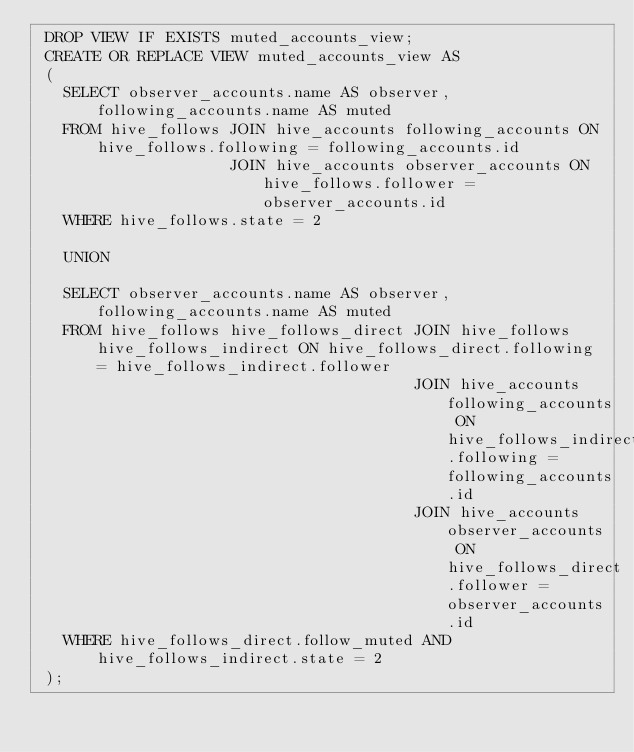<code> <loc_0><loc_0><loc_500><loc_500><_SQL_> DROP VIEW IF EXISTS muted_accounts_view;
 CREATE OR REPLACE VIEW muted_accounts_view AS
 (
   SELECT observer_accounts.name AS observer, following_accounts.name AS muted
   FROM hive_follows JOIN hive_accounts following_accounts ON hive_follows.following = following_accounts.id
                     JOIN hive_accounts observer_accounts ON hive_follows.follower = observer_accounts.id
   WHERE hive_follows.state = 2

   UNION

   SELECT observer_accounts.name AS observer, following_accounts.name AS muted
   FROM hive_follows hive_follows_direct JOIN hive_follows hive_follows_indirect ON hive_follows_direct.following = hive_follows_indirect.follower
                                         JOIN hive_accounts following_accounts ON hive_follows_indirect.following = following_accounts.id
                                         JOIN hive_accounts observer_accounts ON hive_follows_direct.follower = observer_accounts.id
   WHERE hive_follows_direct.follow_muted AND hive_follows_indirect.state = 2
 );
 </code> 